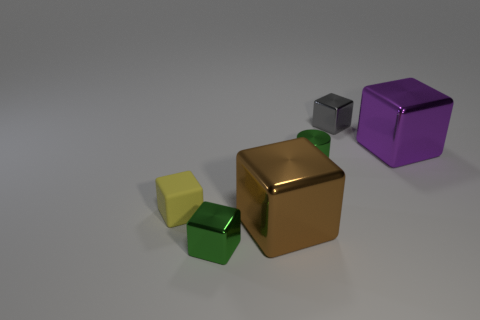Subtract 1 blocks. How many blocks are left? 4 Subtract all metallic blocks. How many blocks are left? 1 Subtract all green blocks. How many blocks are left? 4 Add 1 metal blocks. How many objects exist? 7 Subtract all gray blocks. Subtract all brown balls. How many blocks are left? 4 Subtract all cubes. How many objects are left? 1 Add 6 small blue spheres. How many small blue spheres exist? 6 Subtract 0 yellow spheres. How many objects are left? 6 Subtract all metal things. Subtract all tiny yellow cubes. How many objects are left? 0 Add 5 big purple shiny things. How many big purple shiny things are left? 6 